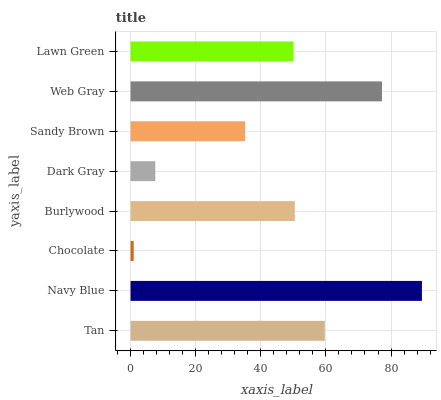Is Chocolate the minimum?
Answer yes or no. Yes. Is Navy Blue the maximum?
Answer yes or no. Yes. Is Navy Blue the minimum?
Answer yes or no. No. Is Chocolate the maximum?
Answer yes or no. No. Is Navy Blue greater than Chocolate?
Answer yes or no. Yes. Is Chocolate less than Navy Blue?
Answer yes or no. Yes. Is Chocolate greater than Navy Blue?
Answer yes or no. No. Is Navy Blue less than Chocolate?
Answer yes or no. No. Is Burlywood the high median?
Answer yes or no. Yes. Is Lawn Green the low median?
Answer yes or no. Yes. Is Navy Blue the high median?
Answer yes or no. No. Is Web Gray the low median?
Answer yes or no. No. 